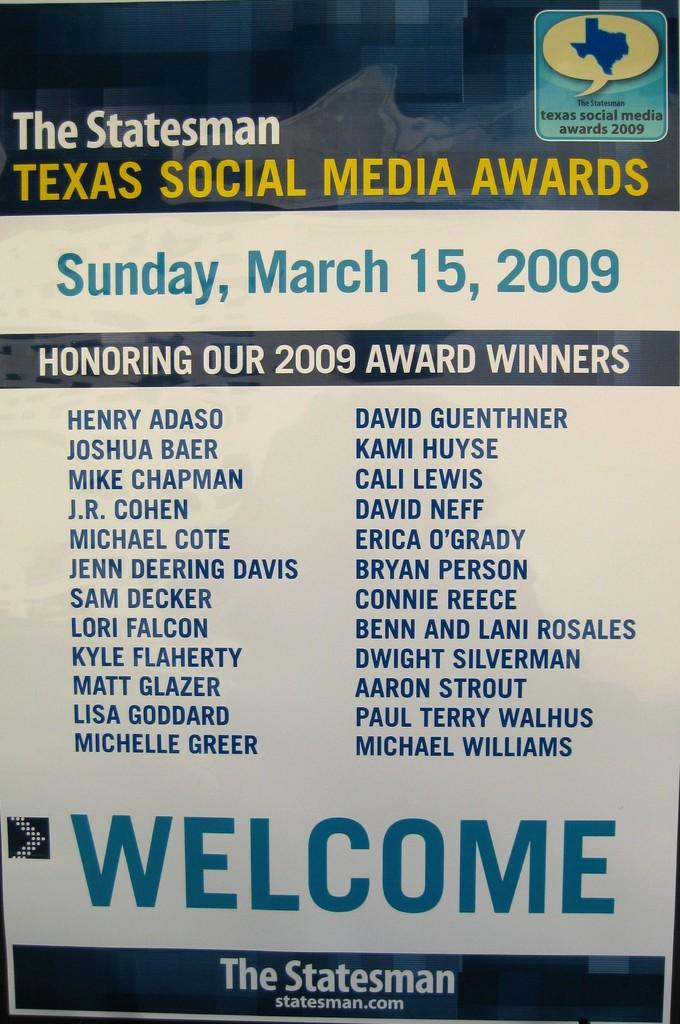<image>
Present a compact description of the photo's key features. The March 15, 2009 Texas Social Media Awards list from Statesman.com. 